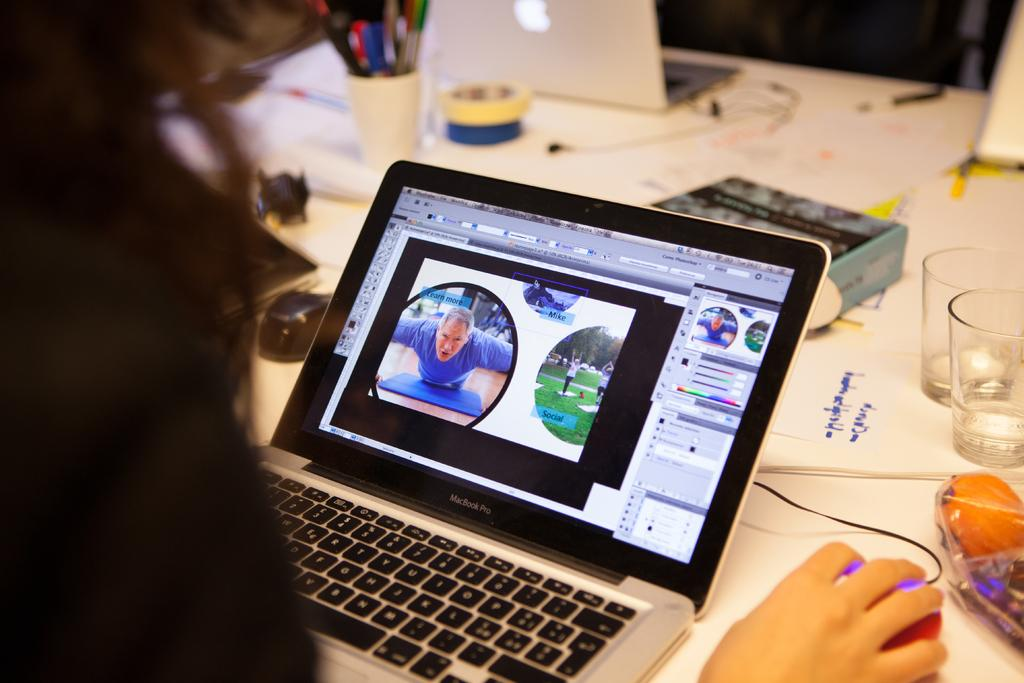What is the person in the image doing? The person is operating a computer mouse in the image. What type of electronic devices can be seen on the table? There are laptops on the table in the image. What type of eyewear is present on the table? Glasses are present on the table in the image. What other objects can be seen on the table? There are other objects on the table in the image. What type of amusement park can be seen in the background of the image? There is no amusement park visible in the image; it is focused on the person and the objects on the table. 